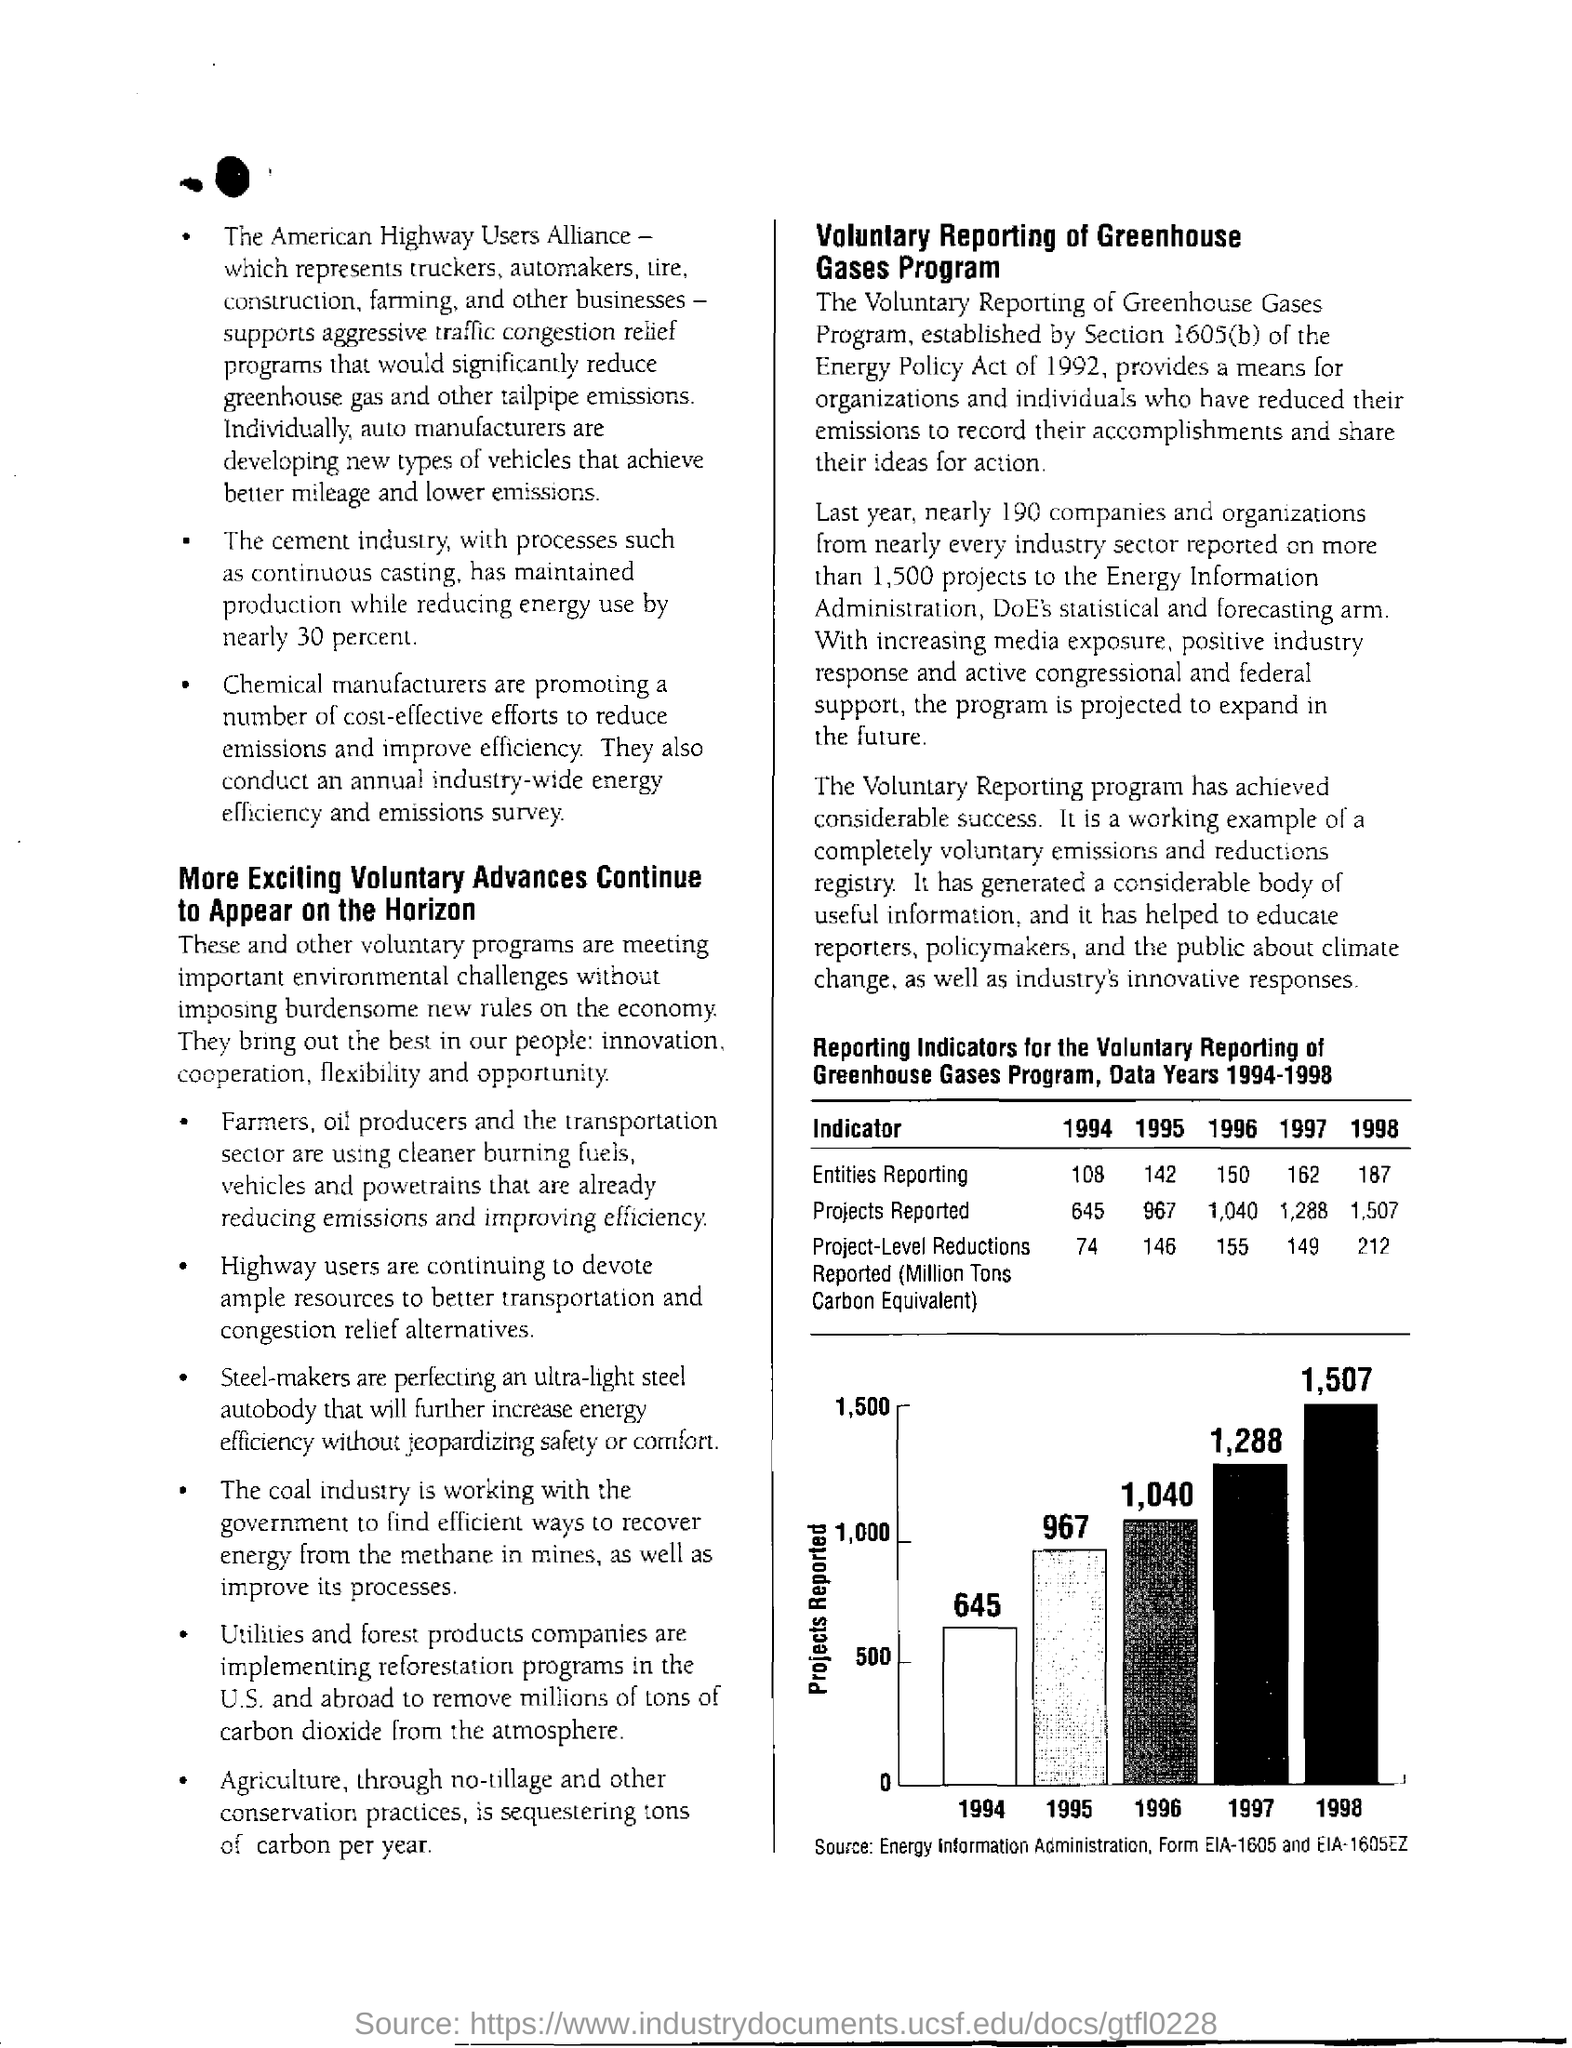Outline some significant characteristics in this image. The cement industry has reduced energy use by 30 percent. The bar graph's source is the Energy Information Administration (EIA) and its forms, EIA-1605 and EIA-1605EZ. In 1998, the most number of projects were reported. 